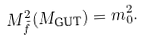<formula> <loc_0><loc_0><loc_500><loc_500>M _ { \tilde { f } } ^ { 2 } ( M _ { \text {GUT} } ) = m _ { 0 } ^ { 2 } .</formula> 